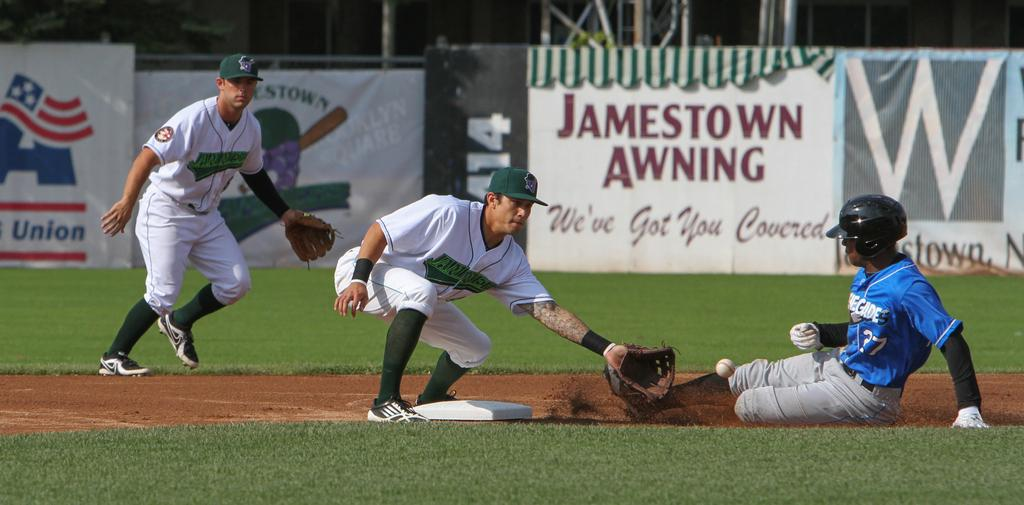<image>
Give a short and clear explanation of the subsequent image. An ad for Jamestown Awning can be seen on a baseball diamond. 